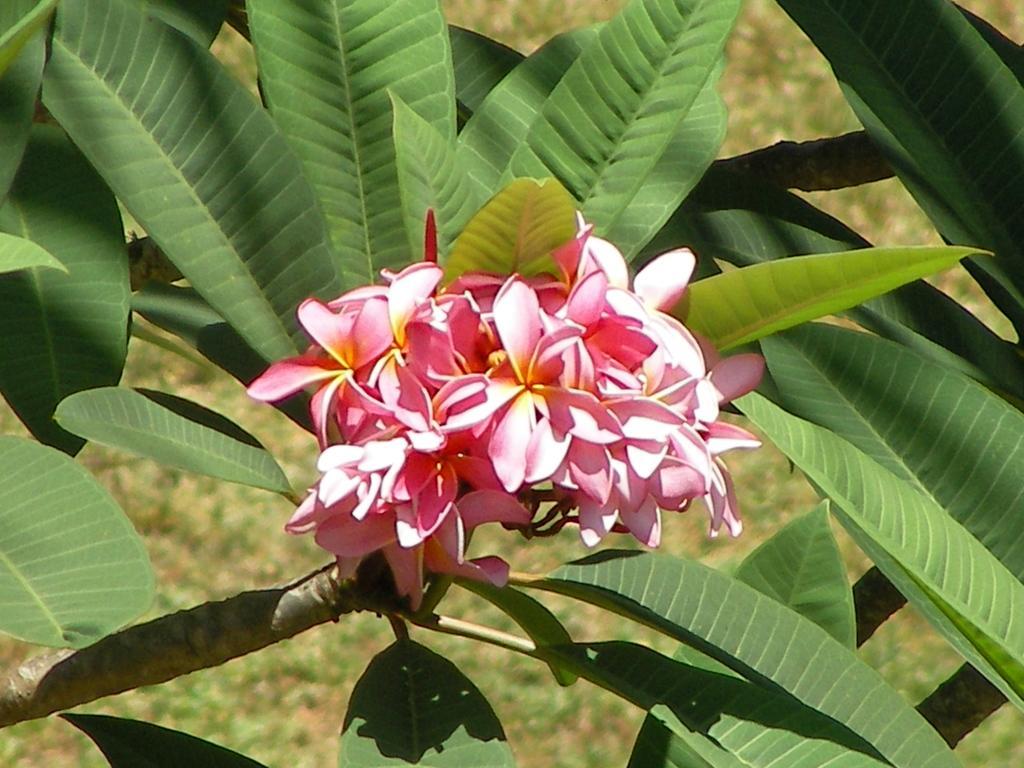In one or two sentences, can you explain what this image depicts? In the center of the image we can see flowers and leaves. In the background there is grass. 